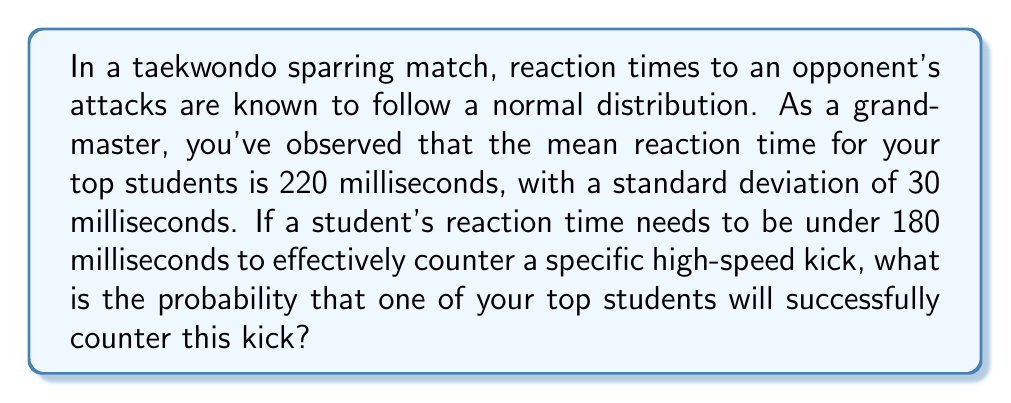Could you help me with this problem? Let's approach this step-by-step:

1) We are dealing with a normal distribution where:
   $\mu = 220$ ms (mean)
   $\sigma = 30$ ms (standard deviation)

2) We need to find the probability that a reaction time is less than 180 ms.

3) To do this, we need to calculate the z-score for 180 ms:

   $$z = \frac{x - \mu}{\sigma} = \frac{180 - 220}{30} = -\frac{40}{30} = -1.33$$

4) Now we need to find the probability that corresponds to this z-score. This is equivalent to finding the area under the standard normal curve to the left of z = -1.33.

5) Using a standard normal table or calculator, we can find that:

   $$P(Z < -1.33) \approx 0.0918$$

6) Therefore, the probability of a reaction time less than 180 ms is approximately 0.0918 or 9.18%.
Answer: 0.0918 or 9.18% 